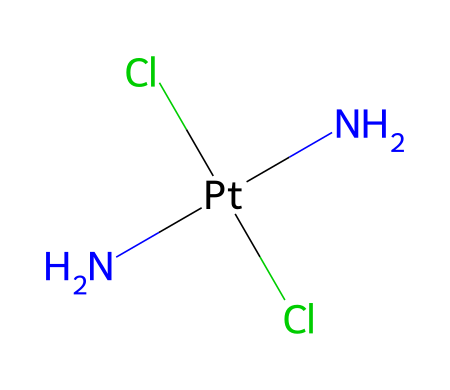What is the central atom in the molecular structure of cisplatin? The chemical structure shows a platinum atom (Pt) bonded to two amine (N) groups and two chloride (Cl) ions, indicating that the central atom is platinum.
Answer: platinum How many nitrogen atoms are present in cisplatin? The SMILES representation contains two nitrogen atoms (N), which can be directly counted, confirming that there are two nitrogen atoms in the structure of cisplatin.
Answer: two What is the coordination number of the platinum atom in cisplatin? The platinum atom is surrounded by four ligands: two amine groups and two chloride ions. The coordination number is calculated based on the number of ligands attached to the central atom, which is four.
Answer: four What type of bonds connect the nitrogen atoms to platinum in cisplatin? The nitrogen atoms are connected to the platinum atom through coordinate covalent bonds, which occur when one atom donates a pair of electrons to form a bond. Therefore, the bonds between nitrogen and platinum can be identified as coordinate bonds.
Answer: coordinate Which type of chemical is cisplatin categorized as due to the presence of a metal in its structure? Cisplatin contains a platinum (metal) atom bonded to various ligands (the nitrogen and chloride groups), qualifying it as an organometallic compound because of the metal-carbon interactions, even though it primarily features coordination bonds with non-carbon elements.
Answer: organometallic Does cisplatin contain any aromatic rings in its structure? The SMILES representation shows only amine and chloride ligands bonded to the platinum atom without any cyclic structures, confirming that the structure does not include aromatic rings.
Answer: no How many chlorine atoms are bonded to the platinum in cisplatin? The structure clearly indicates that there are two chloride ions (Cl) bonded to the platinum (Pt) atom, which can be visually confirmed from the SMILES representation.
Answer: two 